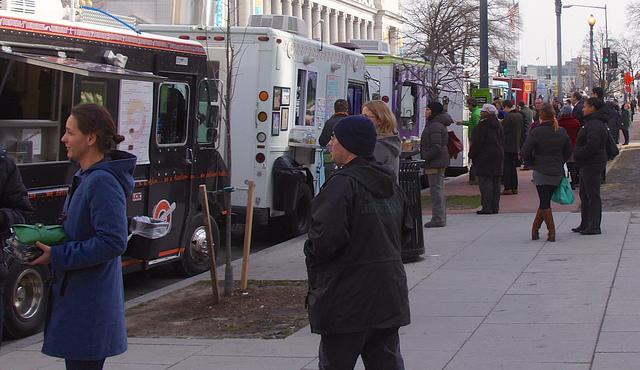What kind of vehicles are shown?
Answer briefly. Food trucks. How many people are shown?
Be succinct. 16. What are these trucks for?
Concise answer only. Food. Is there a wizard in the background?
Be succinct. No. 